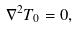<formula> <loc_0><loc_0><loc_500><loc_500>\nabla ^ { 2 } T _ { 0 } = 0 ,</formula> 